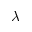<formula> <loc_0><loc_0><loc_500><loc_500>\lambda</formula> 